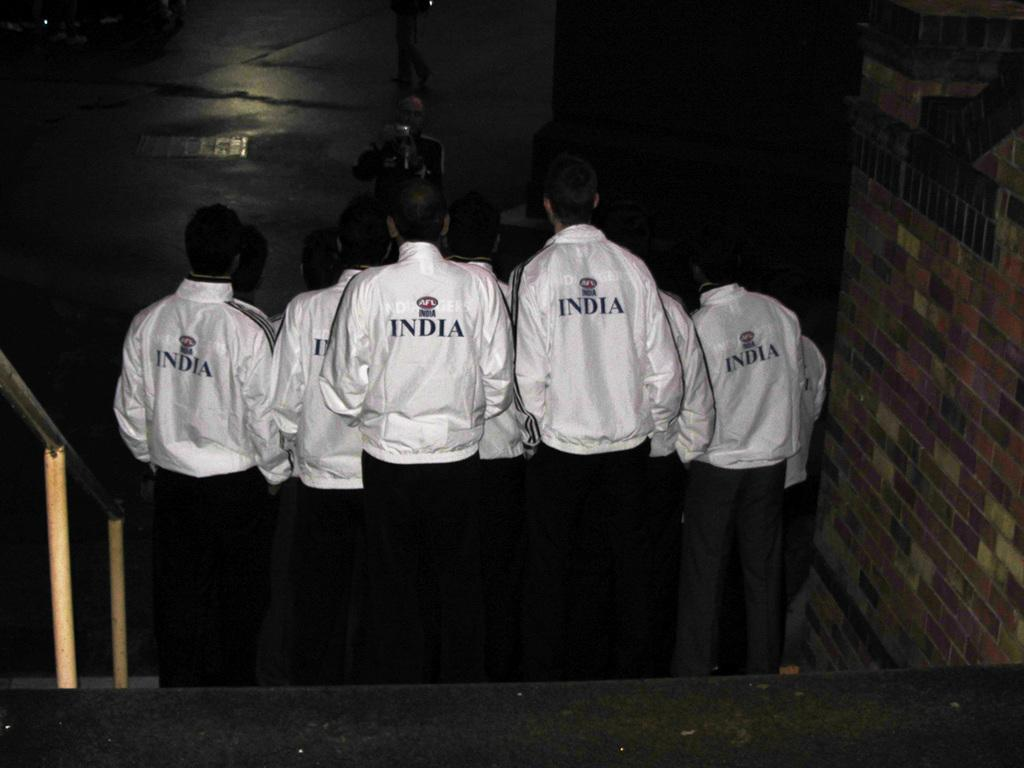<image>
Summarize the visual content of the image. A group of men with white India sweaters taking a photo together. 